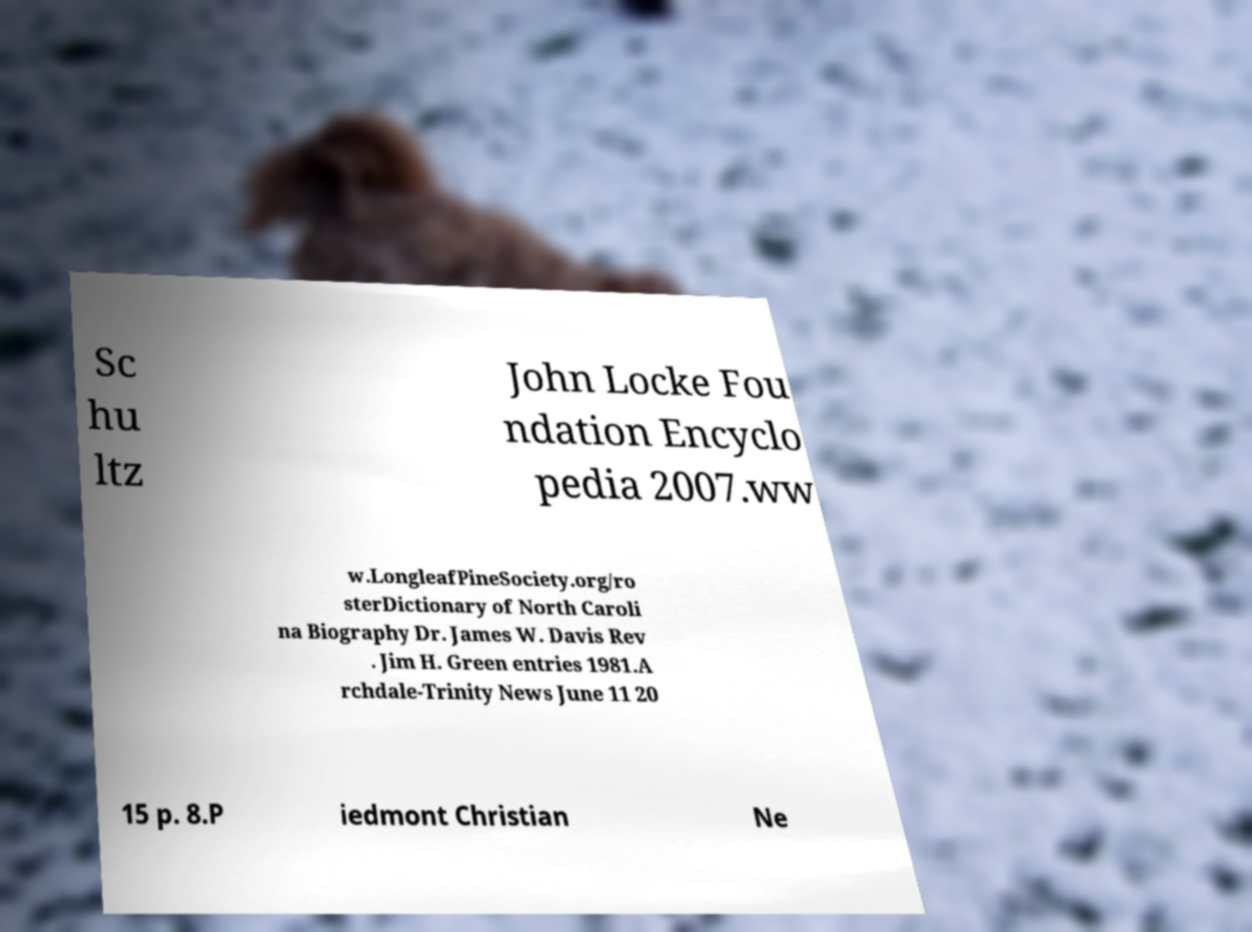Can you accurately transcribe the text from the provided image for me? Sc hu ltz John Locke Fou ndation Encyclo pedia 2007.ww w.LongleafPineSociety.org/ro sterDictionary of North Caroli na Biography Dr. James W. Davis Rev . Jim H. Green entries 1981.A rchdale-Trinity News June 11 20 15 p. 8.P iedmont Christian Ne 